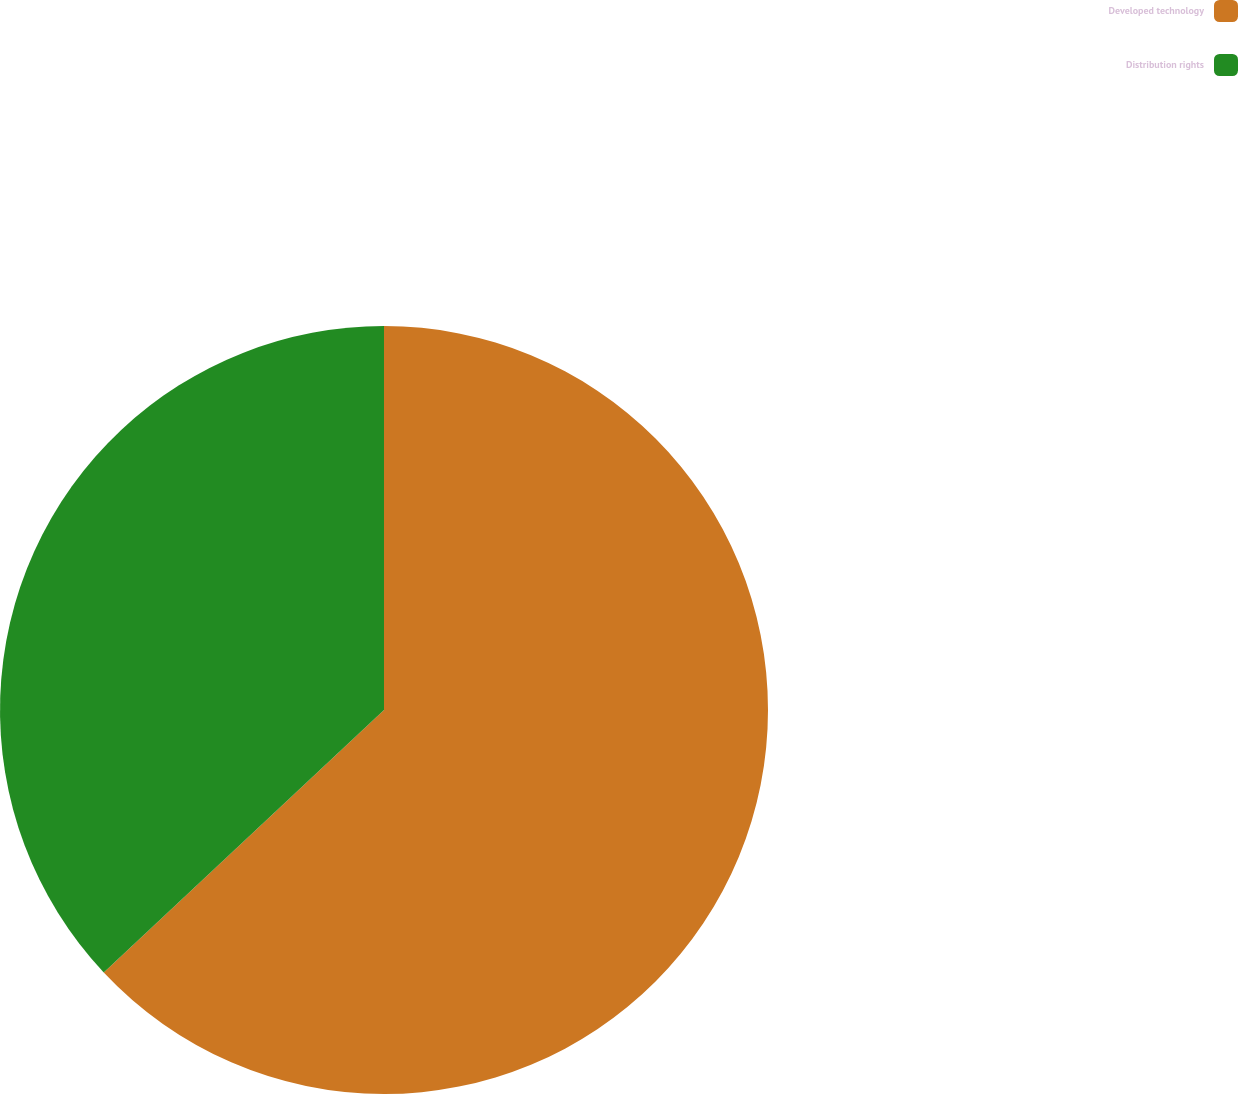Convert chart to OTSL. <chart><loc_0><loc_0><loc_500><loc_500><pie_chart><fcel>Developed technology<fcel>Distribution rights<nl><fcel>63.02%<fcel>36.98%<nl></chart> 